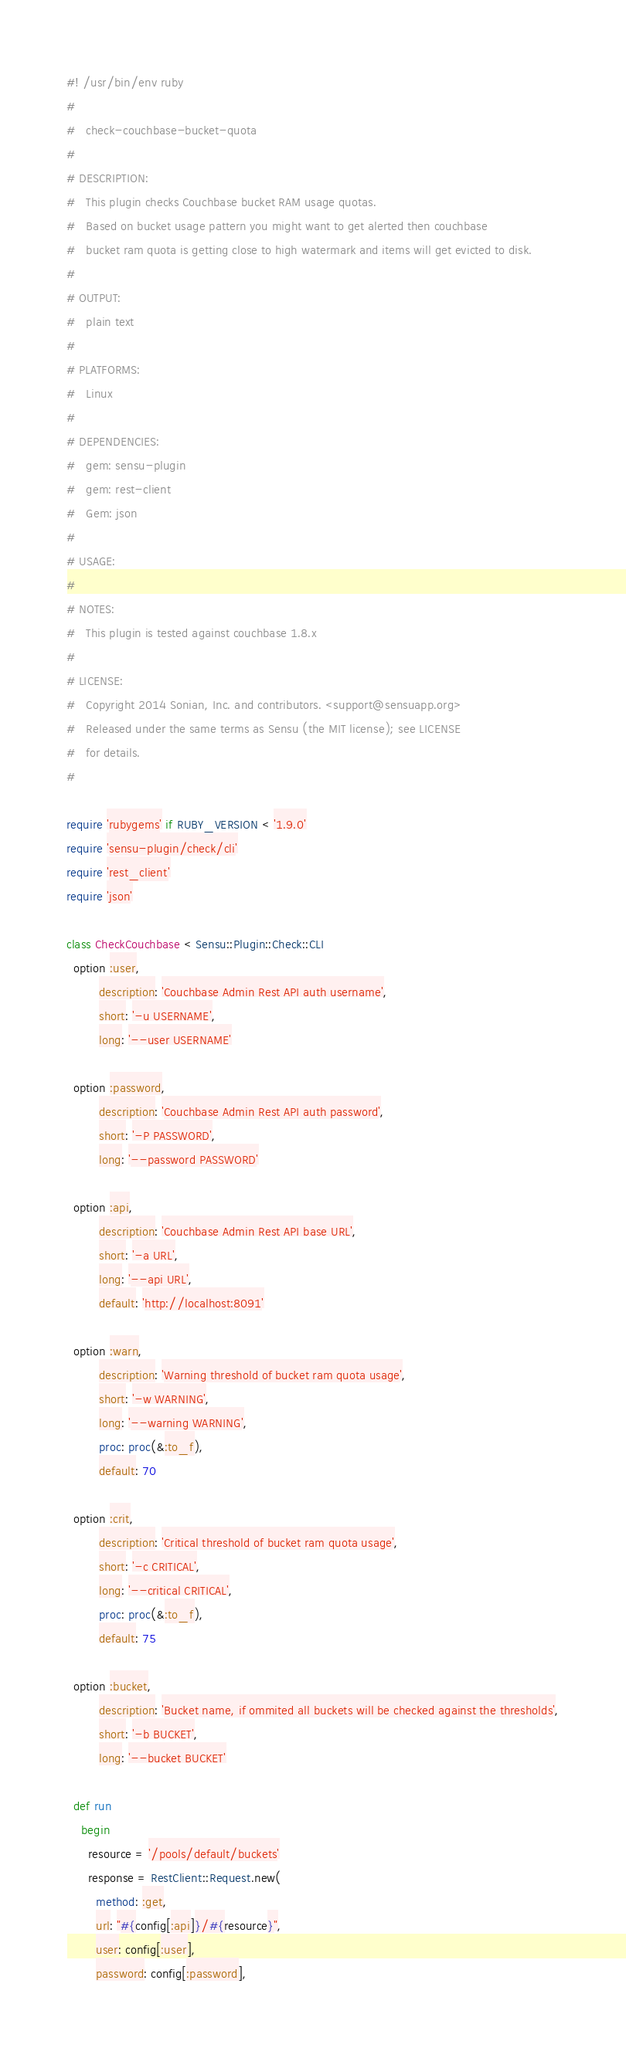<code> <loc_0><loc_0><loc_500><loc_500><_Ruby_>#! /usr/bin/env ruby
#
#   check-couchbase-bucket-quota
#
# DESCRIPTION:
#   This plugin checks Couchbase bucket RAM usage quotas.
#   Based on bucket usage pattern you might want to get alerted then couchbase
#   bucket ram quota is getting close to high watermark and items will get evicted to disk.
#
# OUTPUT:
#   plain text
#
# PLATFORMS:
#   Linux
#
# DEPENDENCIES:
#   gem: sensu-plugin
#   gem: rest-client
#   Gem: json
#
# USAGE:
#
# NOTES:
#   This plugin is tested against couchbase 1.8.x
#
# LICENSE:
#   Copyright 2014 Sonian, Inc. and contributors. <support@sensuapp.org>
#   Released under the same terms as Sensu (the MIT license); see LICENSE
#   for details.
#

require 'rubygems' if RUBY_VERSION < '1.9.0'
require 'sensu-plugin/check/cli'
require 'rest_client'
require 'json'

class CheckCouchbase < Sensu::Plugin::Check::CLI
  option :user,
         description: 'Couchbase Admin Rest API auth username',
         short: '-u USERNAME',
         long: '--user USERNAME'

  option :password,
         description: 'Couchbase Admin Rest API auth password',
         short: '-P PASSWORD',
         long: '--password PASSWORD'

  option :api,
         description: 'Couchbase Admin Rest API base URL',
         short: '-a URL',
         long: '--api URL',
         default: 'http://localhost:8091'

  option :warn,
         description: 'Warning threshold of bucket ram quota usage',
         short: '-w WARNING',
         long: '--warning WARNING',
         proc: proc(&:to_f),
         default: 70

  option :crit,
         description: 'Critical threshold of bucket ram quota usage',
         short: '-c CRITICAL',
         long: '--critical CRITICAL',
         proc: proc(&:to_f),
         default: 75

  option :bucket,
         description: 'Bucket name, if ommited all buckets will be checked against the thresholds',
         short: '-b BUCKET',
         long: '--bucket BUCKET'

  def run
    begin
      resource = '/pools/default/buckets'
      response = RestClient::Request.new(
        method: :get,
        url: "#{config[:api]}/#{resource}",
        user: config[:user],
        password: config[:password],</code> 